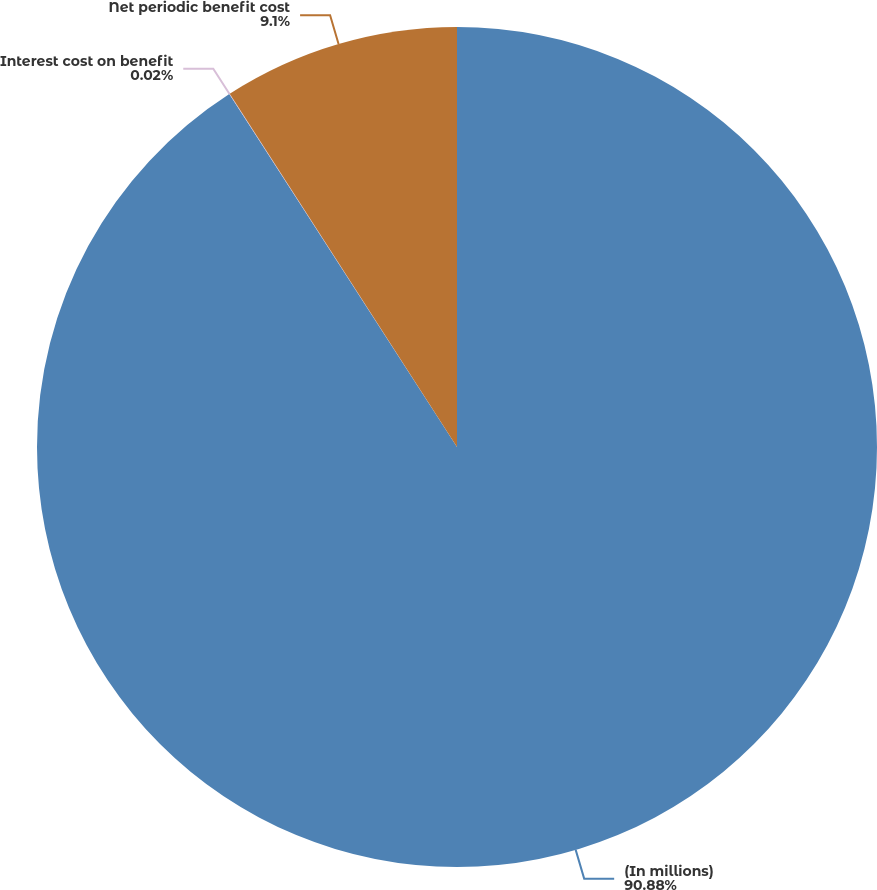Convert chart. <chart><loc_0><loc_0><loc_500><loc_500><pie_chart><fcel>(In millions)<fcel>Interest cost on benefit<fcel>Net periodic benefit cost<nl><fcel>90.88%<fcel>0.02%<fcel>9.1%<nl></chart> 